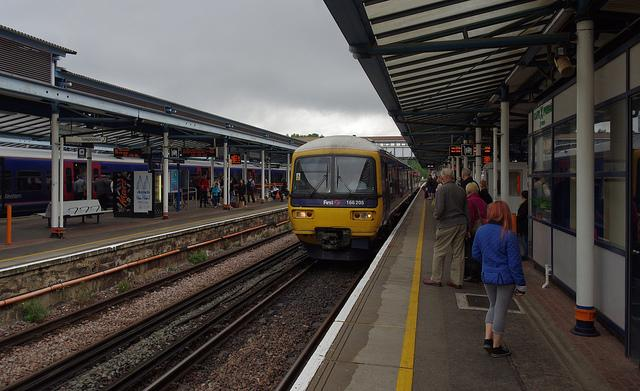At what locale do the people stand? train station 